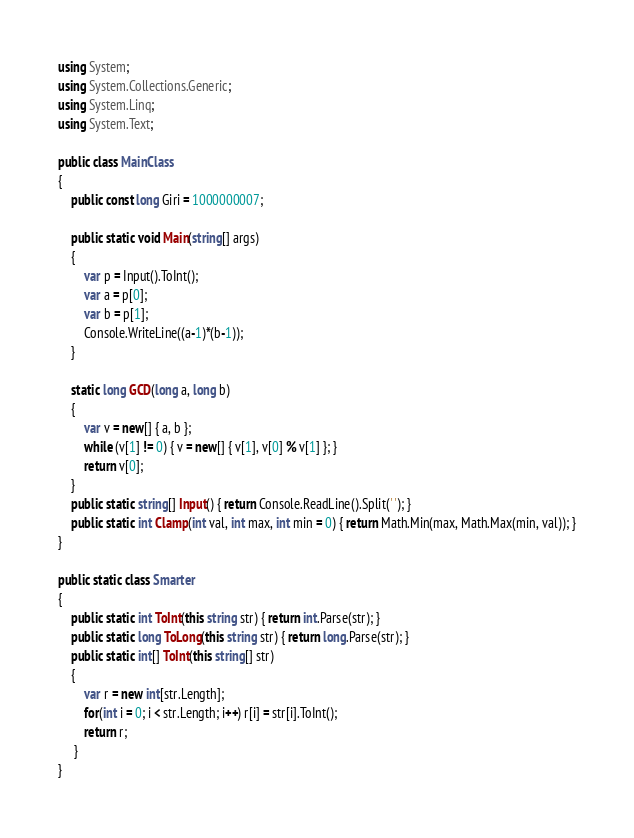Convert code to text. <code><loc_0><loc_0><loc_500><loc_500><_C#_>using System;
using System.Collections.Generic;
using System.Linq;
using System.Text;

public class MainClass
{
	public const long Giri = 1000000007;

	public static void Main(string[] args)
	{
		var p = Input().ToInt();
		var a = p[0];
		var b = p[1];
		Console.WriteLine((a-1)*(b-1));
	}
	
	static long GCD(long a, long b)
	{
		var v = new[] { a, b };
		while (v[1] != 0) { v = new[] { v[1], v[0] % v[1] }; }
		return v[0];
	}
	public static string[] Input() { return Console.ReadLine().Split(' '); }
	public static int Clamp(int val, int max, int min = 0) { return Math.Min(max, Math.Max(min, val)); }
}

public static class Smarter
{
	public static int ToInt(this string str) { return int.Parse(str); }
	public static long ToLong(this string str) { return long.Parse(str); }
	public static int[] ToInt(this string[] str)
	{
		var r = new int[str.Length];
		for(int i = 0; i < str.Length; i++) r[i] = str[i].ToInt();
		return r;
	 }
}

</code> 